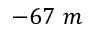<formula> <loc_0><loc_0><loc_500><loc_500>- 6 7 m</formula> 